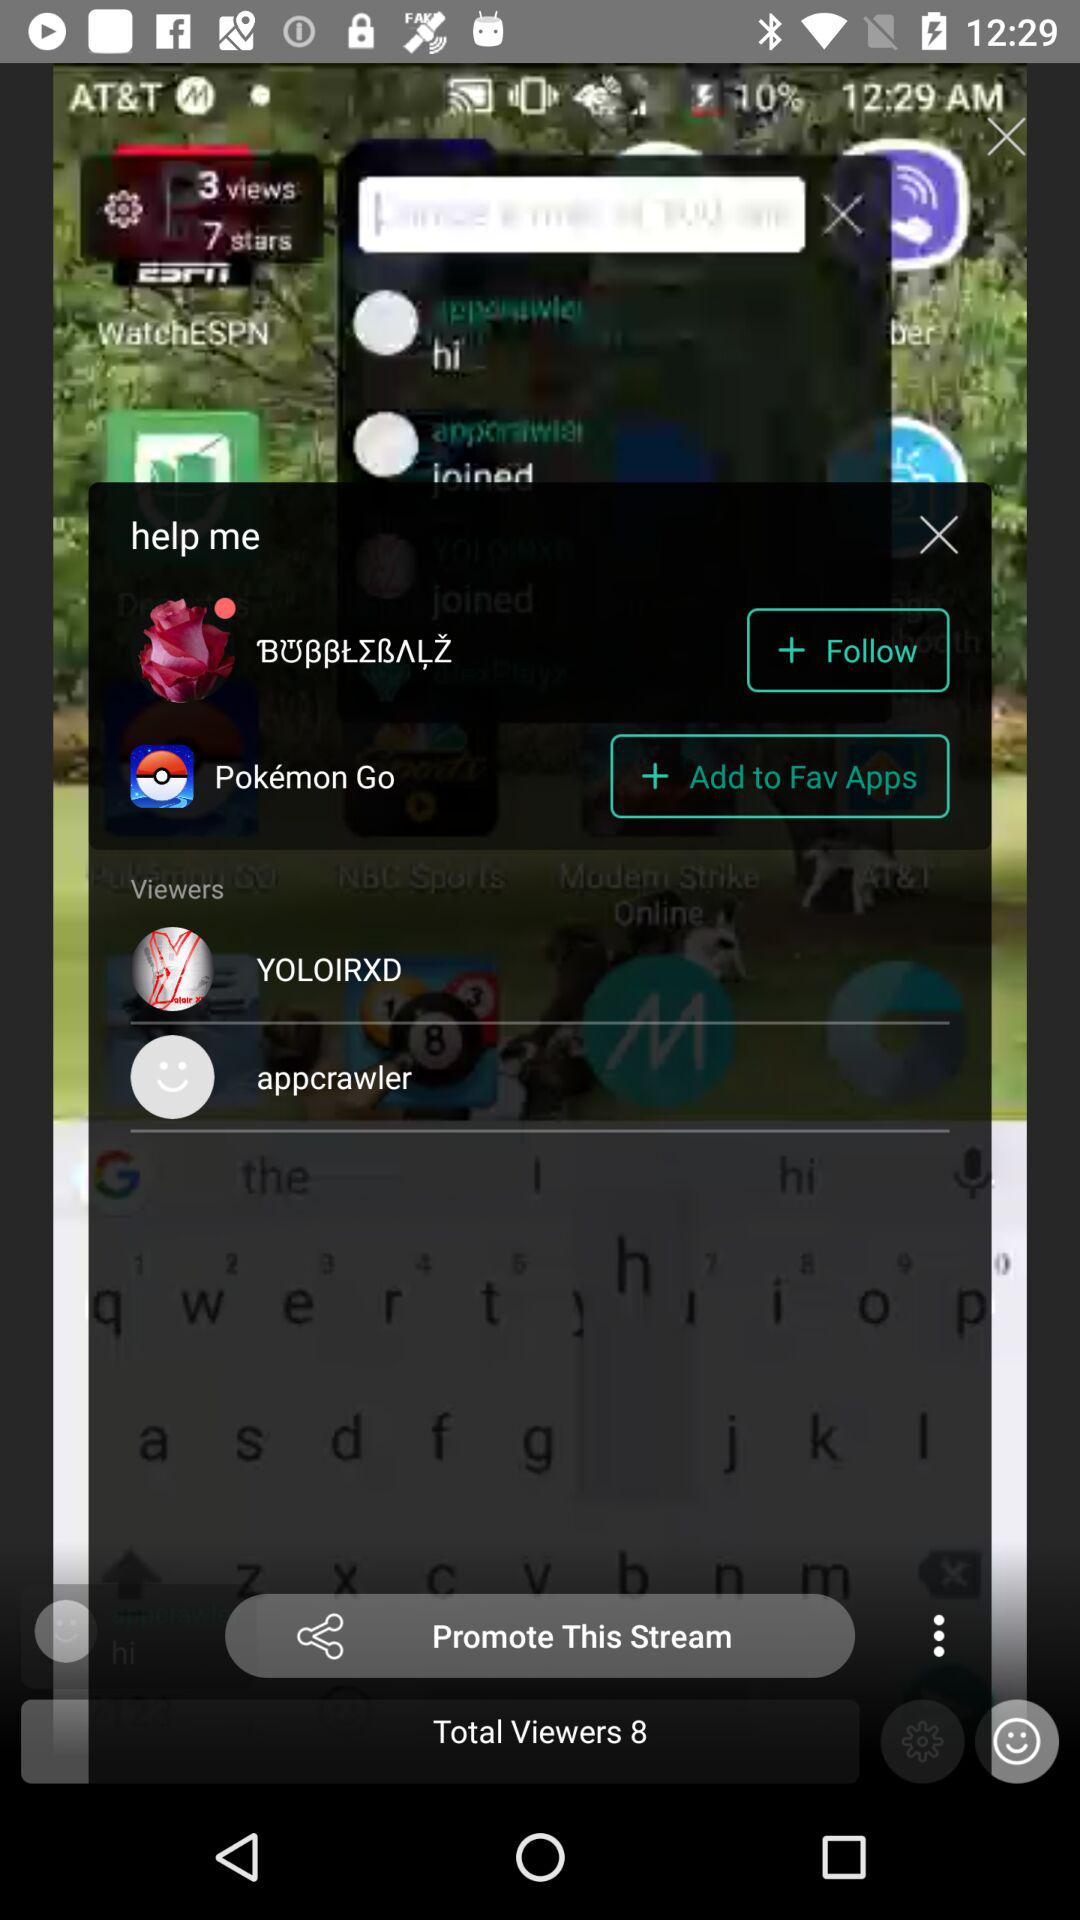How many stars are given there? There are 7 stars. 